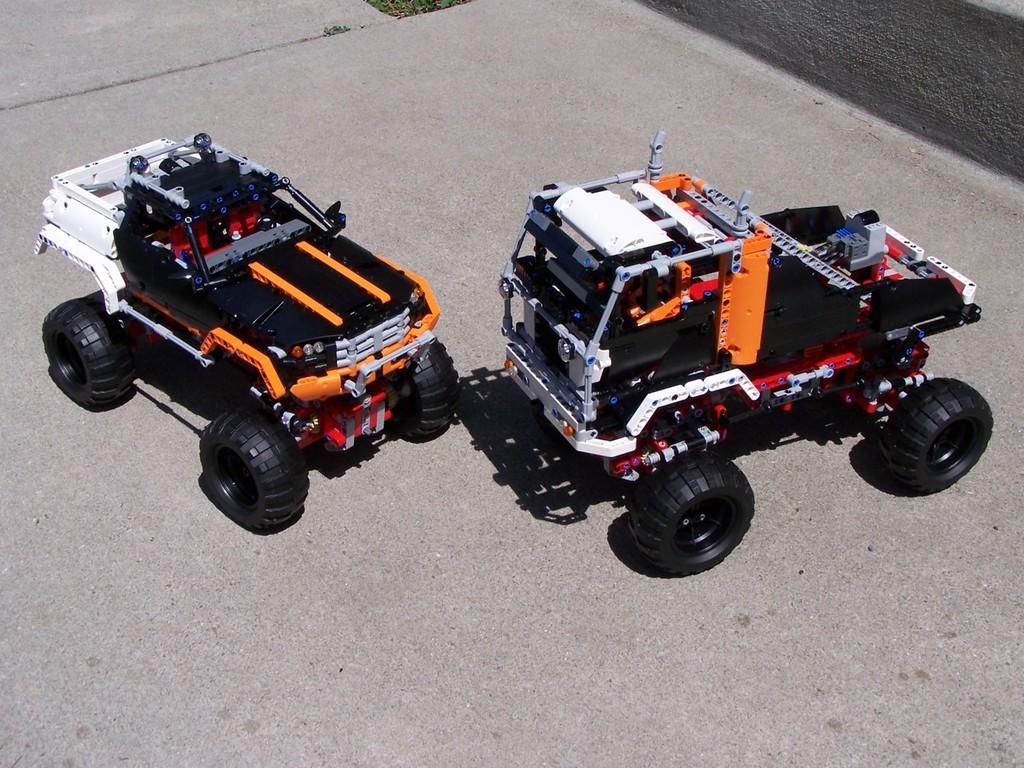Could you give a brief overview of what you see in this image? In this picture we can see toy vehicles on a platform and in the background we can see grass. 